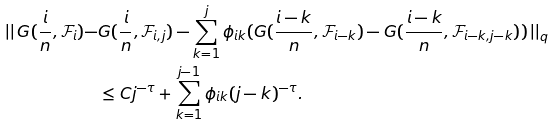Convert formula to latex. <formula><loc_0><loc_0><loc_500><loc_500>\left | \right | G ( \frac { i } { n } , \mathcal { F } _ { i } ) - & G ( \frac { i } { n } , \mathcal { F } _ { i , j } ) - \sum _ { k = 1 } ^ { j } \phi _ { i k } ( G ( \frac { i - k } { n } , \mathcal { F } _ { i - k } ) - G ( \frac { i - k } { n } , \mathcal { F } _ { i - k , j - k } ) ) \left | \right | _ { q } \\ & \leq C j ^ { - \tau } + \sum _ { k = 1 } ^ { j - 1 } \phi _ { i k } ( j - k ) ^ { - \tau } .</formula> 